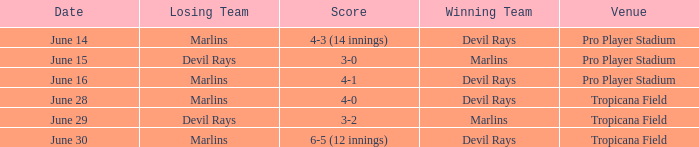On june 14, what was the winning score by the devil rays in pro player stadium? 4-3 (14 innings). 